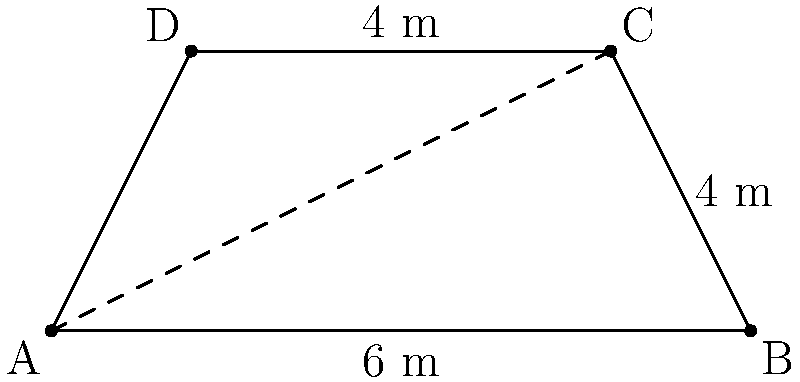A local sustainable energy company in Calgary is planning to install a trapezoid-shaped solar panel on a rooftop. The parallel sides of the trapezoid measure 6 m and 4 m, while the height is 4 m. What is the total area of this solar panel installation? (Note: This eco-friendly project aims to reduce reliance on traditional energy sources.) To find the area of a trapezoid, we can use the formula:

$$A = \frac{1}{2}(b_1 + b_2)h$$

Where:
$A$ = Area of the trapezoid
$b_1$ and $b_2$ = Lengths of the parallel sides
$h$ = Height (perpendicular distance between the parallel sides)

Given:
$b_1 = 6$ m (longer parallel side)
$b_2 = 4$ m (shorter parallel side)
$h = 4$ m (height)

Let's substitute these values into the formula:

$$A = \frac{1}{2}(6 \text{ m} + 4 \text{ m}) \times 4 \text{ m}$$

$$A = \frac{1}{2}(10 \text{ m}) \times 4 \text{ m}$$

$$A = 5 \text{ m} \times 4 \text{ m}$$

$$A = 20 \text{ m}^2$$

Therefore, the total area of the solar panel installation is 20 square meters.
Answer: 20 m² 